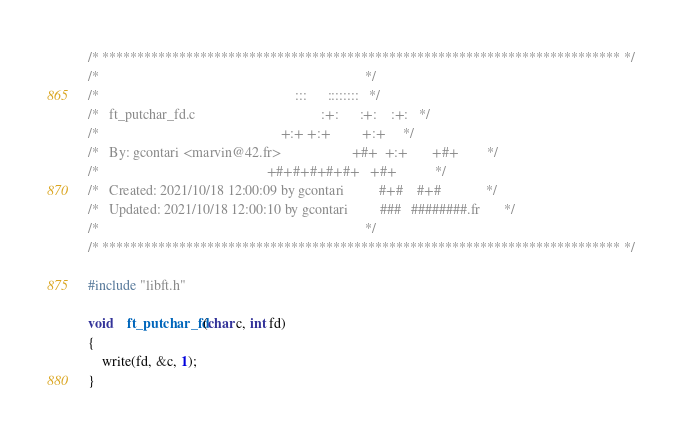Convert code to text. <code><loc_0><loc_0><loc_500><loc_500><_C_>/* ************************************************************************** */
/*                                                                            */
/*                                                        :::      ::::::::   */
/*   ft_putchar_fd.c                                    :+:      :+:    :+:   */
/*                                                    +:+ +:+         +:+     */
/*   By: gcontari <marvin@42.fr>                    +#+  +:+       +#+        */
/*                                                +#+#+#+#+#+   +#+           */
/*   Created: 2021/10/18 12:00:09 by gcontari          #+#    #+#             */
/*   Updated: 2021/10/18 12:00:10 by gcontari         ###   ########.fr       */
/*                                                                            */
/* ************************************************************************** */

#include "libft.h"

void	ft_putchar_fd(char c, int fd)
{
	write(fd, &c, 1);
}
</code> 